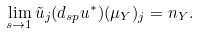Convert formula to latex. <formula><loc_0><loc_0><loc_500><loc_500>\lim _ { s \rightarrow 1 } \tilde { u } _ { j } ( d _ { s p } u ^ { * } ) ( \mu _ { Y } ) _ { j } = n _ { Y } .</formula> 